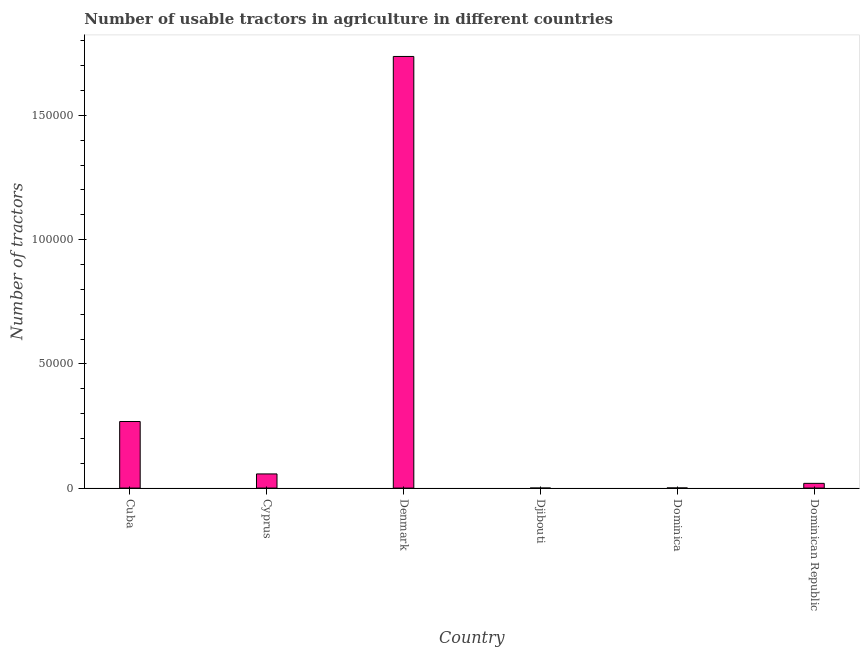Does the graph contain any zero values?
Your response must be concise. No. What is the title of the graph?
Provide a succinct answer. Number of usable tractors in agriculture in different countries. What is the label or title of the X-axis?
Keep it short and to the point. Country. What is the label or title of the Y-axis?
Make the answer very short. Number of tractors. What is the number of tractors in Djibouti?
Your response must be concise. 4. Across all countries, what is the maximum number of tractors?
Keep it short and to the point. 1.74e+05. In which country was the number of tractors minimum?
Make the answer very short. Djibouti. What is the sum of the number of tractors?
Ensure brevity in your answer.  2.08e+05. What is the difference between the number of tractors in Cuba and Djibouti?
Make the answer very short. 2.68e+04. What is the average number of tractors per country?
Give a very brief answer. 3.47e+04. What is the median number of tractors?
Ensure brevity in your answer.  3804.5. In how many countries, is the number of tractors greater than 150000 ?
Your response must be concise. 1. What is the ratio of the number of tractors in Cyprus to that in Dominican Republic?
Provide a short and direct response. 2.98. Is the difference between the number of tractors in Dominica and Dominican Republic greater than the difference between any two countries?
Offer a very short reply. No. What is the difference between the highest and the second highest number of tractors?
Make the answer very short. 1.47e+05. Is the sum of the number of tractors in Dominica and Dominican Republic greater than the maximum number of tractors across all countries?
Your response must be concise. No. What is the difference between the highest and the lowest number of tractors?
Give a very brief answer. 1.74e+05. In how many countries, is the number of tractors greater than the average number of tractors taken over all countries?
Your answer should be very brief. 1. How many countries are there in the graph?
Keep it short and to the point. 6. What is the difference between two consecutive major ticks on the Y-axis?
Offer a very short reply. 5.00e+04. What is the Number of tractors in Cuba?
Give a very brief answer. 2.68e+04. What is the Number of tractors in Cyprus?
Your response must be concise. 5699. What is the Number of tractors of Denmark?
Ensure brevity in your answer.  1.74e+05. What is the Number of tractors in Dominican Republic?
Provide a succinct answer. 1910. What is the difference between the Number of tractors in Cuba and Cyprus?
Your answer should be compact. 2.11e+04. What is the difference between the Number of tractors in Cuba and Denmark?
Your response must be concise. -1.47e+05. What is the difference between the Number of tractors in Cuba and Djibouti?
Ensure brevity in your answer.  2.68e+04. What is the difference between the Number of tractors in Cuba and Dominica?
Your response must be concise. 2.67e+04. What is the difference between the Number of tractors in Cuba and Dominican Republic?
Keep it short and to the point. 2.49e+04. What is the difference between the Number of tractors in Cyprus and Denmark?
Ensure brevity in your answer.  -1.68e+05. What is the difference between the Number of tractors in Cyprus and Djibouti?
Make the answer very short. 5695. What is the difference between the Number of tractors in Cyprus and Dominica?
Provide a short and direct response. 5645. What is the difference between the Number of tractors in Cyprus and Dominican Republic?
Ensure brevity in your answer.  3789. What is the difference between the Number of tractors in Denmark and Djibouti?
Your answer should be compact. 1.74e+05. What is the difference between the Number of tractors in Denmark and Dominica?
Make the answer very short. 1.74e+05. What is the difference between the Number of tractors in Denmark and Dominican Republic?
Ensure brevity in your answer.  1.72e+05. What is the difference between the Number of tractors in Djibouti and Dominica?
Your response must be concise. -50. What is the difference between the Number of tractors in Djibouti and Dominican Republic?
Make the answer very short. -1906. What is the difference between the Number of tractors in Dominica and Dominican Republic?
Offer a terse response. -1856. What is the ratio of the Number of tractors in Cuba to that in Cyprus?
Your answer should be compact. 4.7. What is the ratio of the Number of tractors in Cuba to that in Denmark?
Your response must be concise. 0.15. What is the ratio of the Number of tractors in Cuba to that in Djibouti?
Offer a terse response. 6700. What is the ratio of the Number of tractors in Cuba to that in Dominica?
Your answer should be very brief. 496.3. What is the ratio of the Number of tractors in Cuba to that in Dominican Republic?
Make the answer very short. 14.03. What is the ratio of the Number of tractors in Cyprus to that in Denmark?
Offer a very short reply. 0.03. What is the ratio of the Number of tractors in Cyprus to that in Djibouti?
Make the answer very short. 1424.75. What is the ratio of the Number of tractors in Cyprus to that in Dominica?
Offer a terse response. 105.54. What is the ratio of the Number of tractors in Cyprus to that in Dominican Republic?
Offer a very short reply. 2.98. What is the ratio of the Number of tractors in Denmark to that in Djibouti?
Make the answer very short. 4.34e+04. What is the ratio of the Number of tractors in Denmark to that in Dominica?
Keep it short and to the point. 3217.32. What is the ratio of the Number of tractors in Denmark to that in Dominican Republic?
Your answer should be very brief. 90.96. What is the ratio of the Number of tractors in Djibouti to that in Dominica?
Provide a succinct answer. 0.07. What is the ratio of the Number of tractors in Djibouti to that in Dominican Republic?
Provide a short and direct response. 0. What is the ratio of the Number of tractors in Dominica to that in Dominican Republic?
Provide a short and direct response. 0.03. 